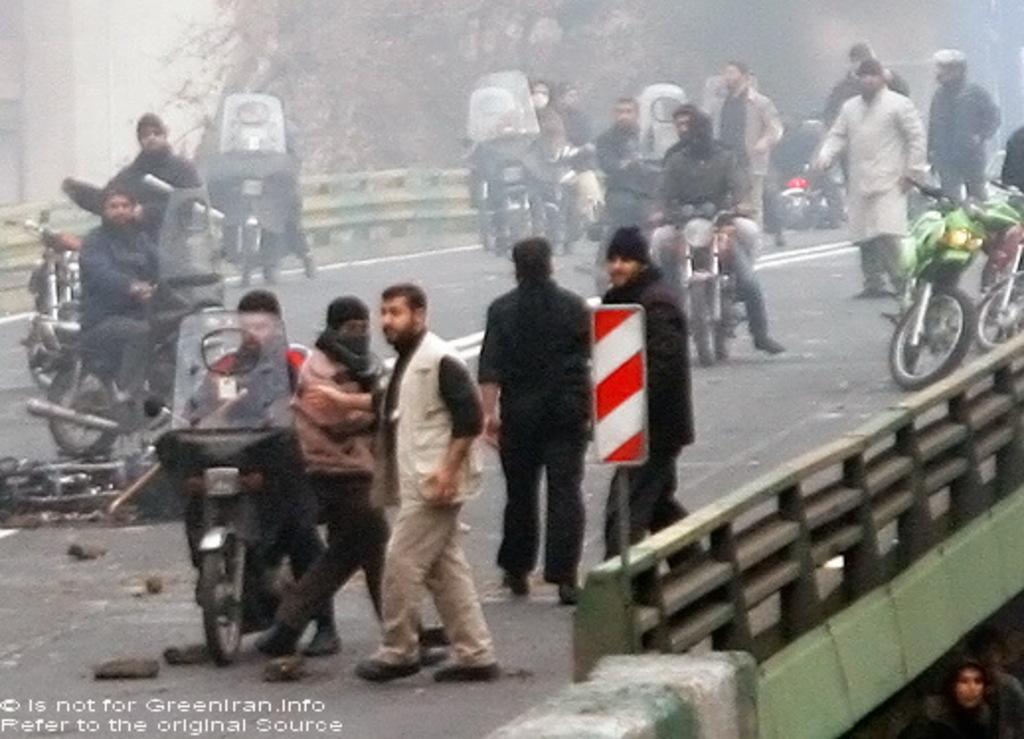Describe this image in one or two sentences. This picture is clicked outside the city. In the middle of the picture, we see the people are standing. We see the people are riding the bikes. At the bottom, we see the road. On either side of the road, we see the road railing. Beside the railing, we see the bikes. In the right bottom, we see a man is standing. In the background, we see the trees and a building in white color. This picture is blurred. 